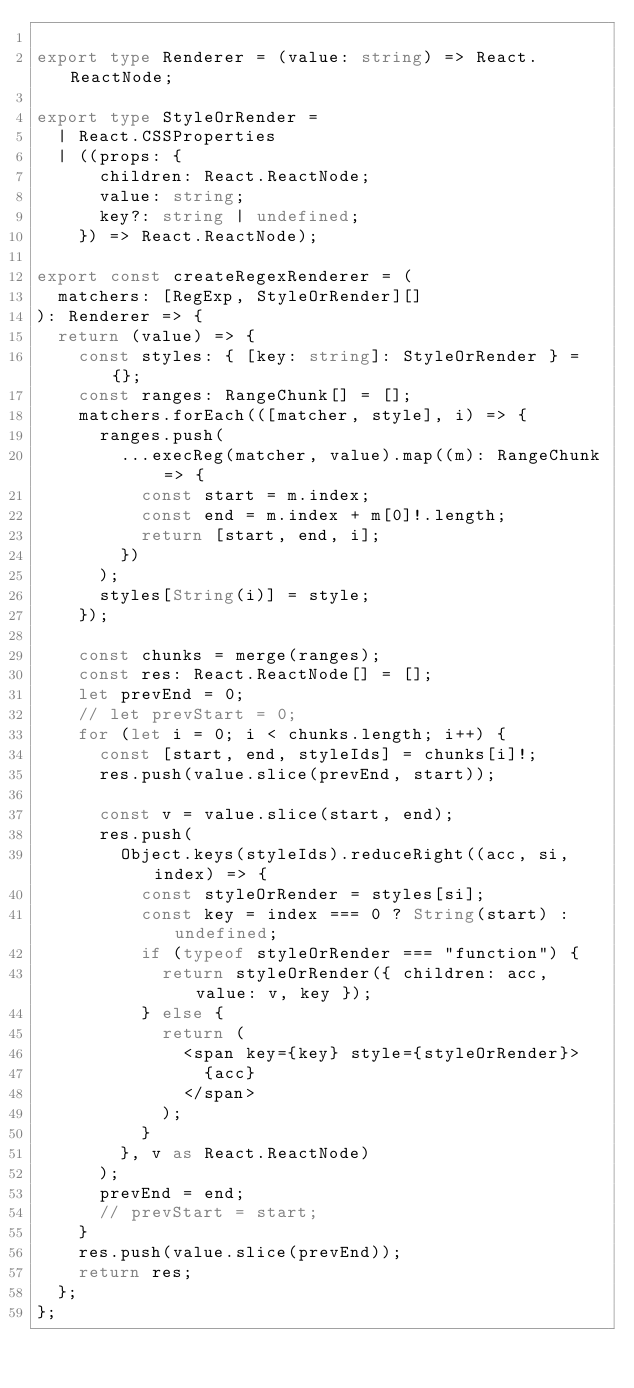Convert code to text. <code><loc_0><loc_0><loc_500><loc_500><_TypeScript_>
export type Renderer = (value: string) => React.ReactNode;

export type StyleOrRender =
  | React.CSSProperties
  | ((props: {
      children: React.ReactNode;
      value: string;
      key?: string | undefined;
    }) => React.ReactNode);

export const createRegexRenderer = (
  matchers: [RegExp, StyleOrRender][]
): Renderer => {
  return (value) => {
    const styles: { [key: string]: StyleOrRender } = {};
    const ranges: RangeChunk[] = [];
    matchers.forEach(([matcher, style], i) => {
      ranges.push(
        ...execReg(matcher, value).map((m): RangeChunk => {
          const start = m.index;
          const end = m.index + m[0]!.length;
          return [start, end, i];
        })
      );
      styles[String(i)] = style;
    });

    const chunks = merge(ranges);
    const res: React.ReactNode[] = [];
    let prevEnd = 0;
    // let prevStart = 0;
    for (let i = 0; i < chunks.length; i++) {
      const [start, end, styleIds] = chunks[i]!;
      res.push(value.slice(prevEnd, start));

      const v = value.slice(start, end);
      res.push(
        Object.keys(styleIds).reduceRight((acc, si, index) => {
          const styleOrRender = styles[si];
          const key = index === 0 ? String(start) : undefined;
          if (typeof styleOrRender === "function") {
            return styleOrRender({ children: acc, value: v, key });
          } else {
            return (
              <span key={key} style={styleOrRender}>
                {acc}
              </span>
            );
          }
        }, v as React.ReactNode)
      );
      prevEnd = end;
      // prevStart = start;
    }
    res.push(value.slice(prevEnd));
    return res;
  };
};
</code> 